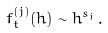<formula> <loc_0><loc_0><loc_500><loc_500>f _ { t } ^ { ( j ) } ( h ) \sim h ^ { s _ { j } } \, .</formula> 